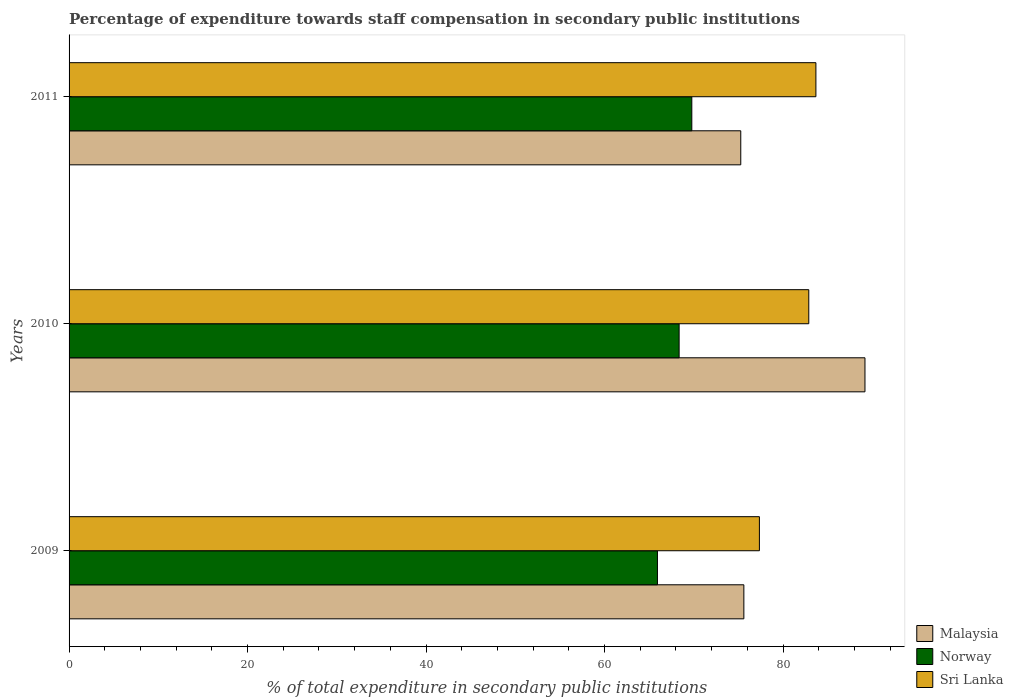Are the number of bars per tick equal to the number of legend labels?
Offer a terse response. Yes. What is the percentage of expenditure towards staff compensation in Norway in 2009?
Your answer should be very brief. 65.93. Across all years, what is the maximum percentage of expenditure towards staff compensation in Malaysia?
Keep it short and to the point. 89.18. Across all years, what is the minimum percentage of expenditure towards staff compensation in Norway?
Keep it short and to the point. 65.93. In which year was the percentage of expenditure towards staff compensation in Malaysia minimum?
Give a very brief answer. 2011. What is the total percentage of expenditure towards staff compensation in Malaysia in the graph?
Your response must be concise. 240.06. What is the difference between the percentage of expenditure towards staff compensation in Norway in 2009 and that in 2011?
Provide a succinct answer. -3.85. What is the difference between the percentage of expenditure towards staff compensation in Norway in 2010 and the percentage of expenditure towards staff compensation in Malaysia in 2011?
Offer a terse response. -6.91. What is the average percentage of expenditure towards staff compensation in Sri Lanka per year?
Your answer should be compact. 81.31. In the year 2009, what is the difference between the percentage of expenditure towards staff compensation in Malaysia and percentage of expenditure towards staff compensation in Norway?
Offer a very short reply. 9.68. In how many years, is the percentage of expenditure towards staff compensation in Sri Lanka greater than 76 %?
Your answer should be compact. 3. What is the ratio of the percentage of expenditure towards staff compensation in Norway in 2009 to that in 2010?
Provide a succinct answer. 0.96. What is the difference between the highest and the second highest percentage of expenditure towards staff compensation in Malaysia?
Keep it short and to the point. 13.57. What is the difference between the highest and the lowest percentage of expenditure towards staff compensation in Sri Lanka?
Offer a very short reply. 6.33. What does the 1st bar from the top in 2010 represents?
Your answer should be very brief. Sri Lanka. What does the 3rd bar from the bottom in 2009 represents?
Your answer should be compact. Sri Lanka. How many bars are there?
Offer a terse response. 9. How many years are there in the graph?
Make the answer very short. 3. Does the graph contain any zero values?
Provide a short and direct response. No. How many legend labels are there?
Your answer should be compact. 3. How are the legend labels stacked?
Your response must be concise. Vertical. What is the title of the graph?
Provide a short and direct response. Percentage of expenditure towards staff compensation in secondary public institutions. What is the label or title of the X-axis?
Offer a terse response. % of total expenditure in secondary public institutions. What is the label or title of the Y-axis?
Your answer should be compact. Years. What is the % of total expenditure in secondary public institutions in Malaysia in 2009?
Provide a succinct answer. 75.61. What is the % of total expenditure in secondary public institutions in Norway in 2009?
Offer a very short reply. 65.93. What is the % of total expenditure in secondary public institutions of Sri Lanka in 2009?
Make the answer very short. 77.35. What is the % of total expenditure in secondary public institutions of Malaysia in 2010?
Provide a short and direct response. 89.18. What is the % of total expenditure in secondary public institutions in Norway in 2010?
Give a very brief answer. 68.36. What is the % of total expenditure in secondary public institutions in Sri Lanka in 2010?
Ensure brevity in your answer.  82.88. What is the % of total expenditure in secondary public institutions in Malaysia in 2011?
Keep it short and to the point. 75.26. What is the % of total expenditure in secondary public institutions of Norway in 2011?
Give a very brief answer. 69.78. What is the % of total expenditure in secondary public institutions of Sri Lanka in 2011?
Offer a terse response. 83.68. Across all years, what is the maximum % of total expenditure in secondary public institutions of Malaysia?
Your answer should be very brief. 89.18. Across all years, what is the maximum % of total expenditure in secondary public institutions in Norway?
Ensure brevity in your answer.  69.78. Across all years, what is the maximum % of total expenditure in secondary public institutions of Sri Lanka?
Your answer should be very brief. 83.68. Across all years, what is the minimum % of total expenditure in secondary public institutions of Malaysia?
Give a very brief answer. 75.26. Across all years, what is the minimum % of total expenditure in secondary public institutions in Norway?
Your answer should be very brief. 65.93. Across all years, what is the minimum % of total expenditure in secondary public institutions of Sri Lanka?
Your answer should be very brief. 77.35. What is the total % of total expenditure in secondary public institutions in Malaysia in the graph?
Offer a terse response. 240.06. What is the total % of total expenditure in secondary public institutions in Norway in the graph?
Provide a succinct answer. 204.06. What is the total % of total expenditure in secondary public institutions in Sri Lanka in the graph?
Provide a succinct answer. 243.92. What is the difference between the % of total expenditure in secondary public institutions in Malaysia in 2009 and that in 2010?
Provide a succinct answer. -13.57. What is the difference between the % of total expenditure in secondary public institutions in Norway in 2009 and that in 2010?
Make the answer very short. -2.43. What is the difference between the % of total expenditure in secondary public institutions in Sri Lanka in 2009 and that in 2010?
Ensure brevity in your answer.  -5.53. What is the difference between the % of total expenditure in secondary public institutions of Malaysia in 2009 and that in 2011?
Your answer should be compact. 0.35. What is the difference between the % of total expenditure in secondary public institutions in Norway in 2009 and that in 2011?
Offer a very short reply. -3.85. What is the difference between the % of total expenditure in secondary public institutions in Sri Lanka in 2009 and that in 2011?
Make the answer very short. -6.33. What is the difference between the % of total expenditure in secondary public institutions in Malaysia in 2010 and that in 2011?
Provide a short and direct response. 13.92. What is the difference between the % of total expenditure in secondary public institutions in Norway in 2010 and that in 2011?
Your response must be concise. -1.42. What is the difference between the % of total expenditure in secondary public institutions of Sri Lanka in 2010 and that in 2011?
Your answer should be compact. -0.8. What is the difference between the % of total expenditure in secondary public institutions of Malaysia in 2009 and the % of total expenditure in secondary public institutions of Norway in 2010?
Keep it short and to the point. 7.25. What is the difference between the % of total expenditure in secondary public institutions of Malaysia in 2009 and the % of total expenditure in secondary public institutions of Sri Lanka in 2010?
Your answer should be compact. -7.27. What is the difference between the % of total expenditure in secondary public institutions of Norway in 2009 and the % of total expenditure in secondary public institutions of Sri Lanka in 2010?
Give a very brief answer. -16.96. What is the difference between the % of total expenditure in secondary public institutions in Malaysia in 2009 and the % of total expenditure in secondary public institutions in Norway in 2011?
Offer a very short reply. 5.83. What is the difference between the % of total expenditure in secondary public institutions in Malaysia in 2009 and the % of total expenditure in secondary public institutions in Sri Lanka in 2011?
Offer a very short reply. -8.07. What is the difference between the % of total expenditure in secondary public institutions of Norway in 2009 and the % of total expenditure in secondary public institutions of Sri Lanka in 2011?
Keep it short and to the point. -17.75. What is the difference between the % of total expenditure in secondary public institutions in Malaysia in 2010 and the % of total expenditure in secondary public institutions in Norway in 2011?
Your response must be concise. 19.4. What is the difference between the % of total expenditure in secondary public institutions in Malaysia in 2010 and the % of total expenditure in secondary public institutions in Sri Lanka in 2011?
Give a very brief answer. 5.5. What is the difference between the % of total expenditure in secondary public institutions of Norway in 2010 and the % of total expenditure in secondary public institutions of Sri Lanka in 2011?
Make the answer very short. -15.33. What is the average % of total expenditure in secondary public institutions of Malaysia per year?
Your answer should be very brief. 80.02. What is the average % of total expenditure in secondary public institutions in Norway per year?
Keep it short and to the point. 68.02. What is the average % of total expenditure in secondary public institutions in Sri Lanka per year?
Your answer should be very brief. 81.31. In the year 2009, what is the difference between the % of total expenditure in secondary public institutions of Malaysia and % of total expenditure in secondary public institutions of Norway?
Offer a terse response. 9.68. In the year 2009, what is the difference between the % of total expenditure in secondary public institutions in Malaysia and % of total expenditure in secondary public institutions in Sri Lanka?
Provide a short and direct response. -1.74. In the year 2009, what is the difference between the % of total expenditure in secondary public institutions in Norway and % of total expenditure in secondary public institutions in Sri Lanka?
Keep it short and to the point. -11.42. In the year 2010, what is the difference between the % of total expenditure in secondary public institutions of Malaysia and % of total expenditure in secondary public institutions of Norway?
Offer a very short reply. 20.82. In the year 2010, what is the difference between the % of total expenditure in secondary public institutions in Malaysia and % of total expenditure in secondary public institutions in Sri Lanka?
Keep it short and to the point. 6.3. In the year 2010, what is the difference between the % of total expenditure in secondary public institutions in Norway and % of total expenditure in secondary public institutions in Sri Lanka?
Provide a succinct answer. -14.53. In the year 2011, what is the difference between the % of total expenditure in secondary public institutions in Malaysia and % of total expenditure in secondary public institutions in Norway?
Provide a short and direct response. 5.49. In the year 2011, what is the difference between the % of total expenditure in secondary public institutions in Malaysia and % of total expenditure in secondary public institutions in Sri Lanka?
Your answer should be very brief. -8.42. In the year 2011, what is the difference between the % of total expenditure in secondary public institutions in Norway and % of total expenditure in secondary public institutions in Sri Lanka?
Offer a very short reply. -13.91. What is the ratio of the % of total expenditure in secondary public institutions of Malaysia in 2009 to that in 2010?
Give a very brief answer. 0.85. What is the ratio of the % of total expenditure in secondary public institutions of Norway in 2009 to that in 2010?
Provide a short and direct response. 0.96. What is the ratio of the % of total expenditure in secondary public institutions in Sri Lanka in 2009 to that in 2010?
Your response must be concise. 0.93. What is the ratio of the % of total expenditure in secondary public institutions in Malaysia in 2009 to that in 2011?
Your response must be concise. 1. What is the ratio of the % of total expenditure in secondary public institutions of Norway in 2009 to that in 2011?
Make the answer very short. 0.94. What is the ratio of the % of total expenditure in secondary public institutions in Sri Lanka in 2009 to that in 2011?
Provide a short and direct response. 0.92. What is the ratio of the % of total expenditure in secondary public institutions in Malaysia in 2010 to that in 2011?
Provide a short and direct response. 1.18. What is the ratio of the % of total expenditure in secondary public institutions in Norway in 2010 to that in 2011?
Provide a short and direct response. 0.98. What is the difference between the highest and the second highest % of total expenditure in secondary public institutions of Malaysia?
Give a very brief answer. 13.57. What is the difference between the highest and the second highest % of total expenditure in secondary public institutions of Norway?
Keep it short and to the point. 1.42. What is the difference between the highest and the second highest % of total expenditure in secondary public institutions in Sri Lanka?
Give a very brief answer. 0.8. What is the difference between the highest and the lowest % of total expenditure in secondary public institutions of Malaysia?
Your answer should be compact. 13.92. What is the difference between the highest and the lowest % of total expenditure in secondary public institutions of Norway?
Provide a short and direct response. 3.85. What is the difference between the highest and the lowest % of total expenditure in secondary public institutions of Sri Lanka?
Provide a succinct answer. 6.33. 